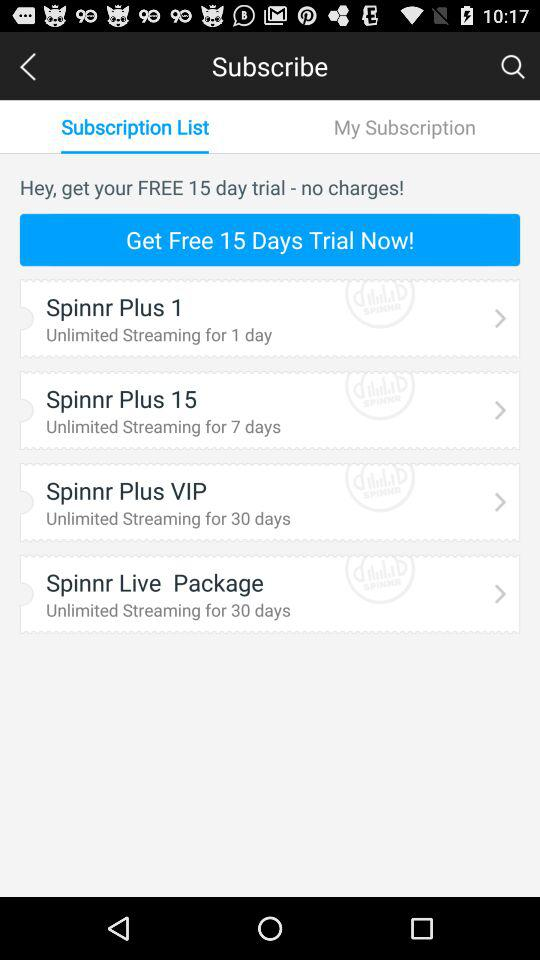Which tab is currently selected? The selected tab is "Subscription List". 